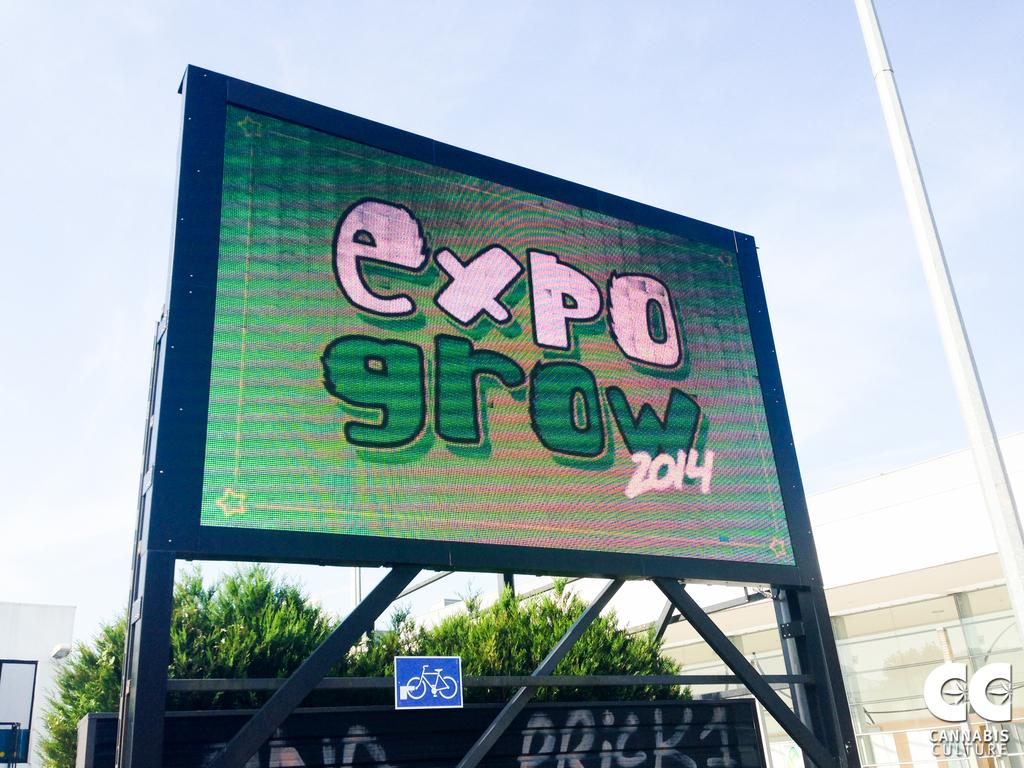<image>
Offer a succinct explanation of the picture presented. A street banner with Expo wrote in pink and Grow wrote in green. 